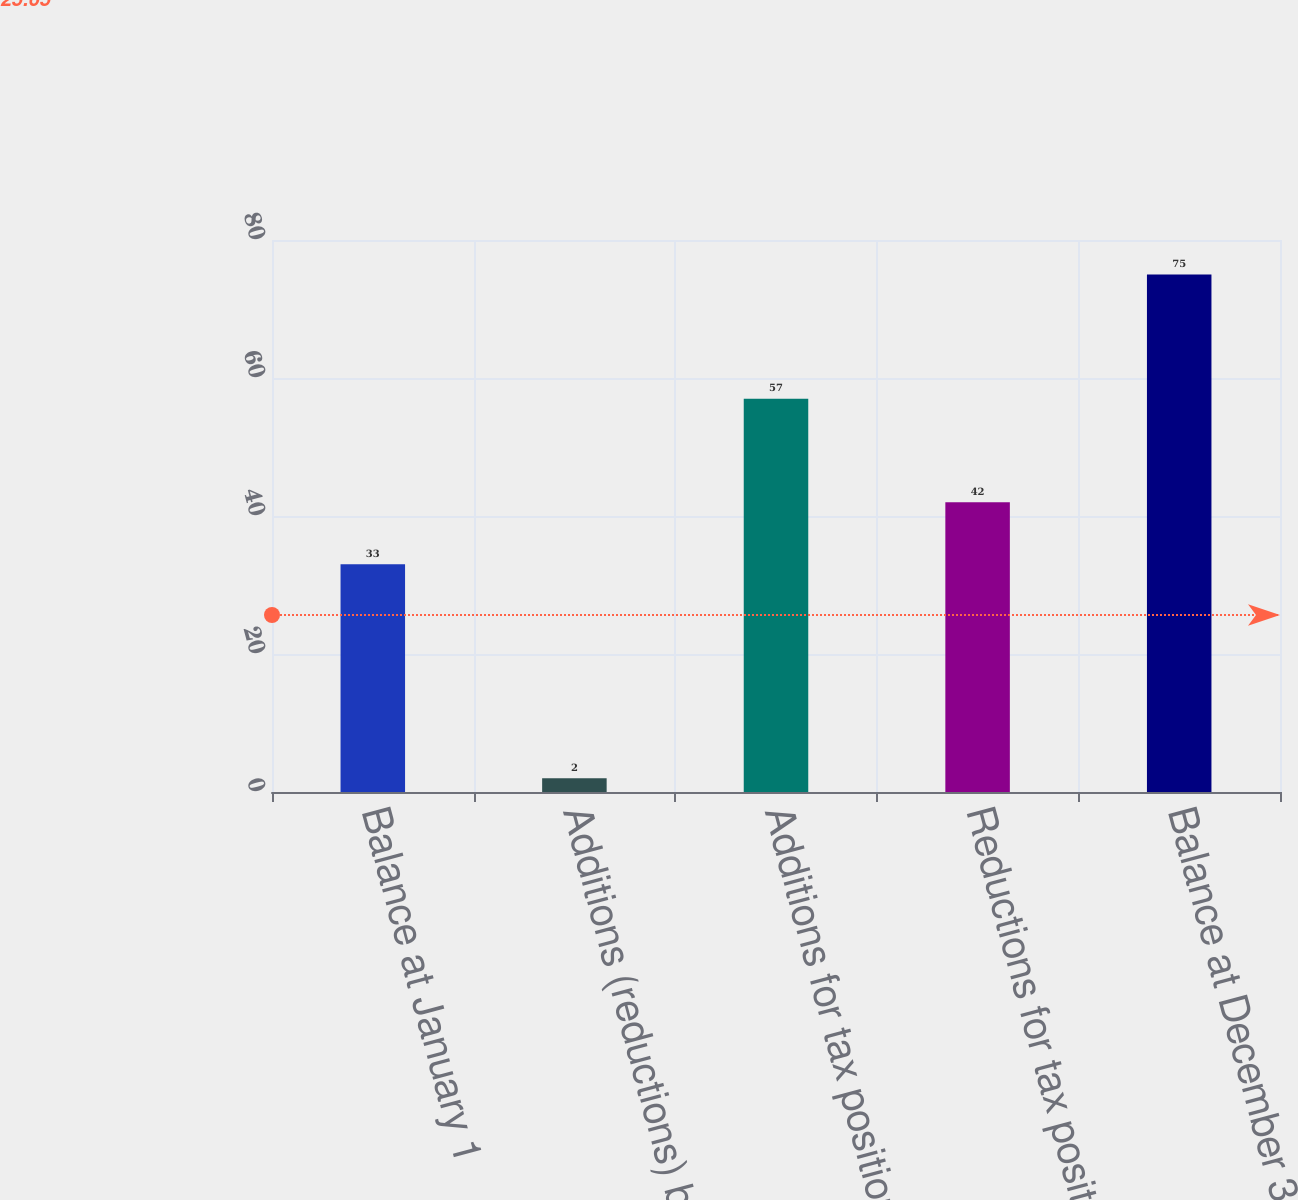Convert chart to OTSL. <chart><loc_0><loc_0><loc_500><loc_500><bar_chart><fcel>Balance at January 1<fcel>Additions (reductions) based<fcel>Additions for tax positions of<fcel>Reductions for tax positions<fcel>Balance at December 31<nl><fcel>33<fcel>2<fcel>57<fcel>42<fcel>75<nl></chart> 